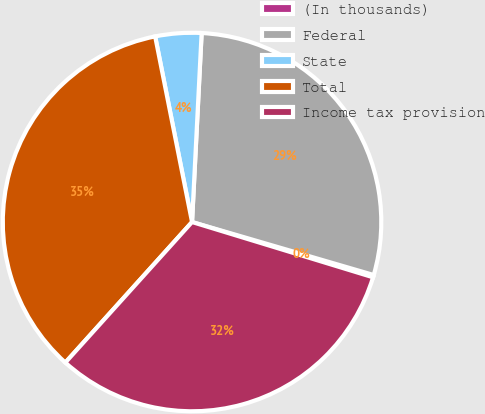Convert chart to OTSL. <chart><loc_0><loc_0><loc_500><loc_500><pie_chart><fcel>(In thousands)<fcel>Federal<fcel>State<fcel>Total<fcel>Income tax provision<nl><fcel>0.2%<fcel>28.71%<fcel>3.93%<fcel>35.2%<fcel>31.96%<nl></chart> 